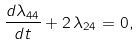<formula> <loc_0><loc_0><loc_500><loc_500>\frac { d \lambda _ { 4 4 } } { d t } + 2 \, \lambda _ { 2 4 } = 0 ,</formula> 